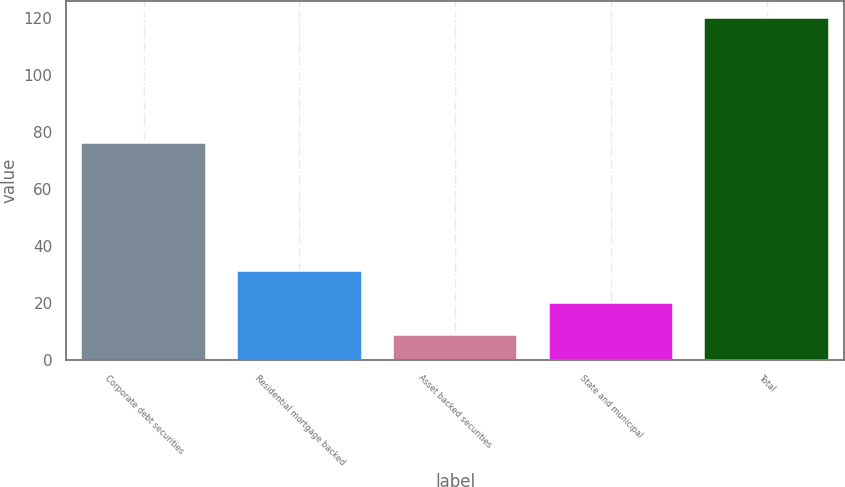Convert chart. <chart><loc_0><loc_0><loc_500><loc_500><bar_chart><fcel>Corporate debt securities<fcel>Residential mortgage backed<fcel>Asset backed securities<fcel>State and municipal<fcel>Total<nl><fcel>76<fcel>31.2<fcel>9<fcel>20.1<fcel>120<nl></chart> 